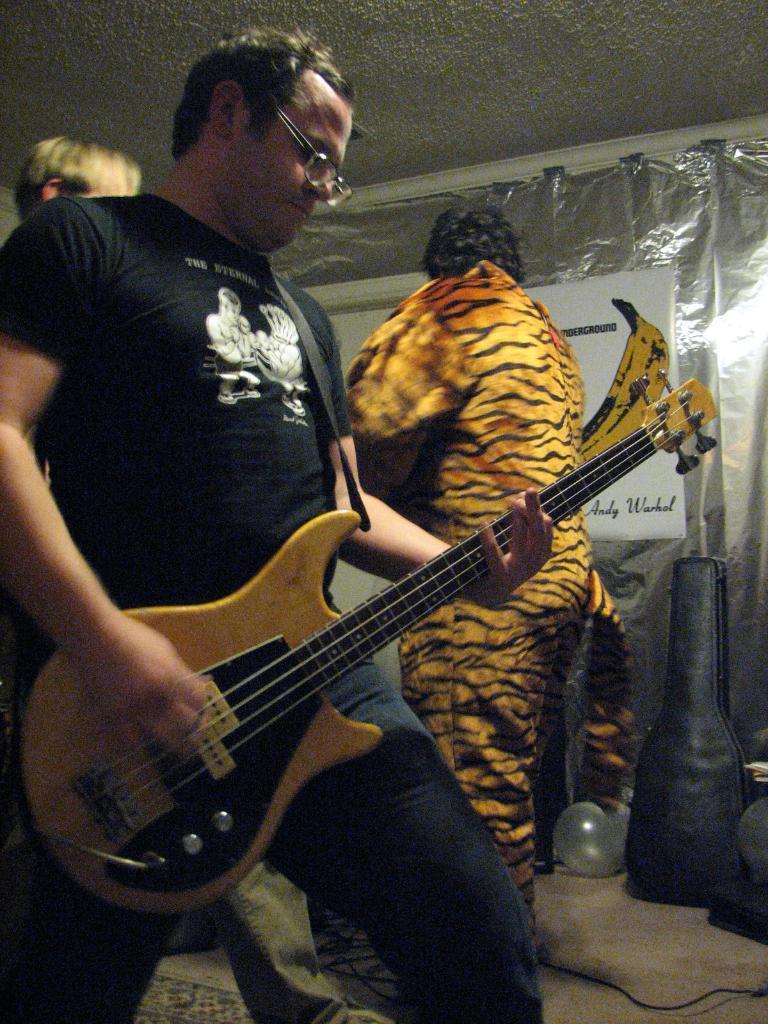Please provide a concise description of this image. In this picture we can see man holding guitar in his hand wore spectacle and in background we can see man wore tiger costume and here we can see plastic cover with banner to it, balloon, wire. 